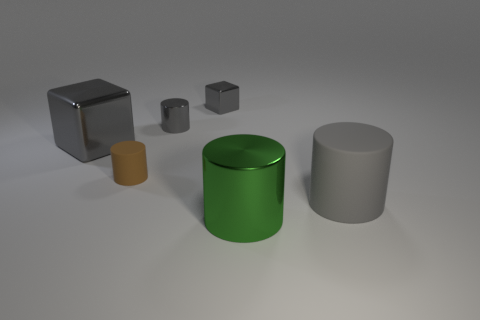Subtract all gray blocks. How many were subtracted if there are1gray blocks left? 1 Subtract 1 cylinders. How many cylinders are left? 3 Add 1 big gray metallic cubes. How many objects exist? 7 Subtract all cylinders. How many objects are left? 2 Add 4 large rubber things. How many large rubber things exist? 5 Subtract 1 brown cylinders. How many objects are left? 5 Subtract all tiny brown things. Subtract all big cyan shiny cylinders. How many objects are left? 5 Add 6 gray shiny things. How many gray shiny things are left? 9 